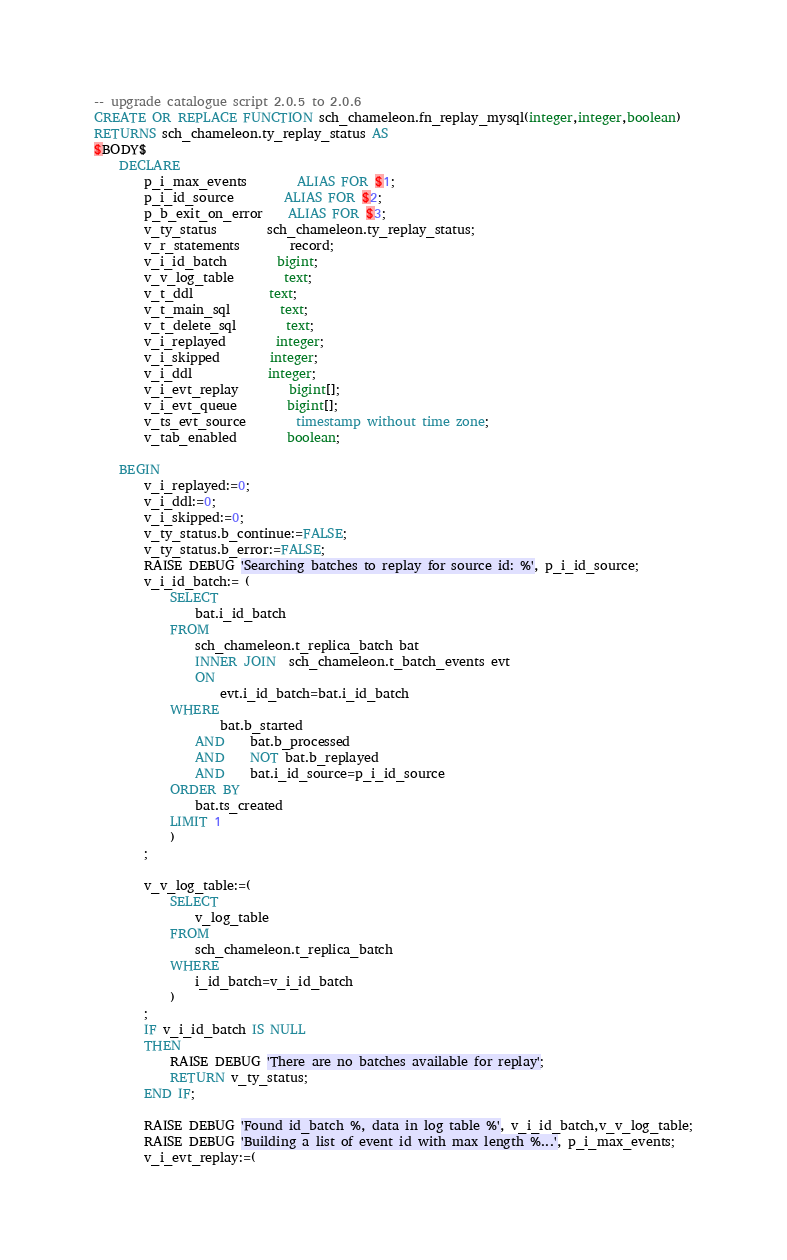Convert code to text. <code><loc_0><loc_0><loc_500><loc_500><_SQL_>-- upgrade catalogue script 2.0.5 to 2.0.6
CREATE OR REPLACE FUNCTION sch_chameleon.fn_replay_mysql(integer,integer,boolean)
RETURNS sch_chameleon.ty_replay_status AS
$BODY$
	DECLARE
		p_i_max_events		ALIAS FOR $1;
		p_i_id_source		ALIAS FOR $2;
		p_b_exit_on_error	ALIAS FOR $3;
		v_ty_status		sch_chameleon.ty_replay_status;
		v_r_statements		record;
		v_i_id_batch		bigint;
		v_v_log_table		text;
		v_t_ddl			text;
		v_t_main_sql		text;
		v_t_delete_sql		text;
		v_i_replayed		integer;
		v_i_skipped		integer;
		v_i_ddl			integer;
		v_i_evt_replay		bigint[];
		v_i_evt_queue		bigint[];
		v_ts_evt_source		timestamp without time zone;
		v_tab_enabled		boolean;

	BEGIN
		v_i_replayed:=0;
		v_i_ddl:=0;
		v_i_skipped:=0;
		v_ty_status.b_continue:=FALSE;
		v_ty_status.b_error:=FALSE;		
		RAISE DEBUG 'Searching batches to replay for source id: %', p_i_id_source;
		v_i_id_batch:= (
			SELECT 
				bat.i_id_batch 
			FROM 
				sch_chameleon.t_replica_batch bat
				INNER JOIN  sch_chameleon.t_batch_events evt
				ON
					evt.i_id_batch=bat.i_id_batch
			WHERE 
					bat.b_started 
				AND	bat.b_processed 
				AND	NOT bat.b_replayed
				AND	bat.i_id_source=p_i_id_source
			ORDER BY 
				bat.ts_created 
			LIMIT 1
			)
		;

		v_v_log_table:=(
			SELECT 
				v_log_table
			FROM 
				sch_chameleon.t_replica_batch 
			WHERE 
				i_id_batch=v_i_id_batch
			)
		;
		IF v_i_id_batch IS NULL 
		THEN
			RAISE DEBUG 'There are no batches available for replay';
			RETURN v_ty_status;
		END IF;
		
		RAISE DEBUG 'Found id_batch %, data in log table %', v_i_id_batch,v_v_log_table;
		RAISE DEBUG 'Building a list of event id with max length %...', p_i_max_events;
		v_i_evt_replay:=(</code> 